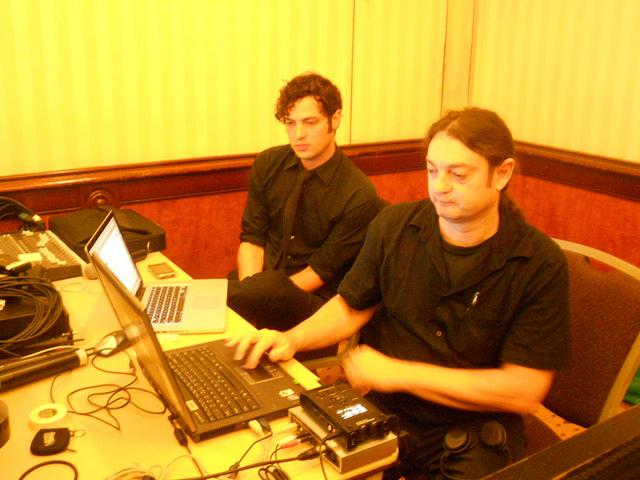Why is he looking at the other guy's laptop?

Choices:
A) is curious
B) is teaching
C) stealing information
D) is learning is learning 